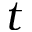Convert formula to latex. <formula><loc_0><loc_0><loc_500><loc_500>t</formula> 